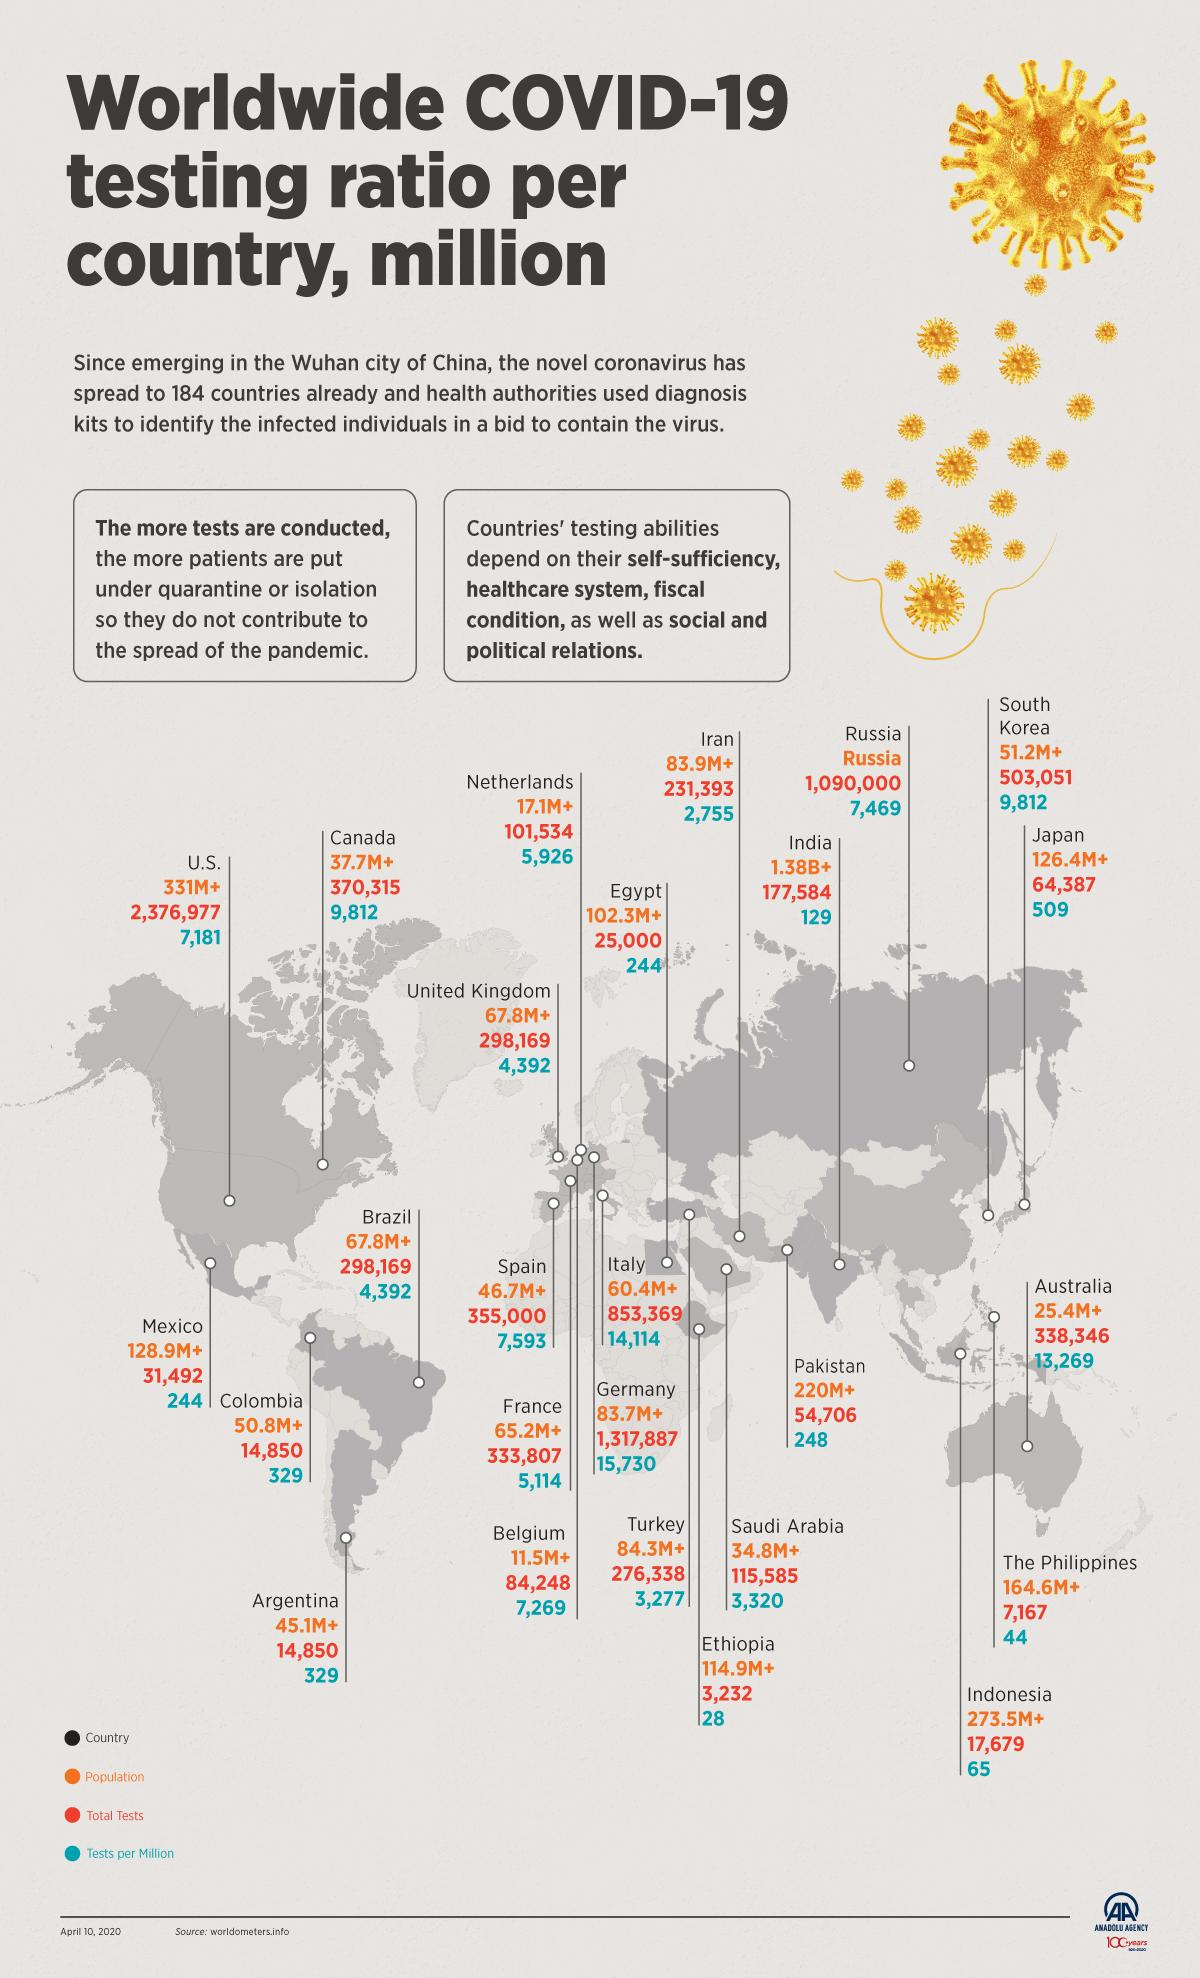Point out several critical features in this image. As of April 10, 2020, a total of 355,000 COVID-19 tests had been conducted in Spain. As of April 10, 2020, India had conducted 129 COVID-19 tests per million population, indicating a significant increase in testing efforts to contain the spread of the virus. As of April 10, 2020, a total of 64,387 COVID-19 tests had been conducted in Japan. As of April 10, 2020, the U.S. had conducted a total of 7,181 COVID-19 tests per million population. As of April 10, 2020, the estimated population of India is approximately 1.38 billion people. 